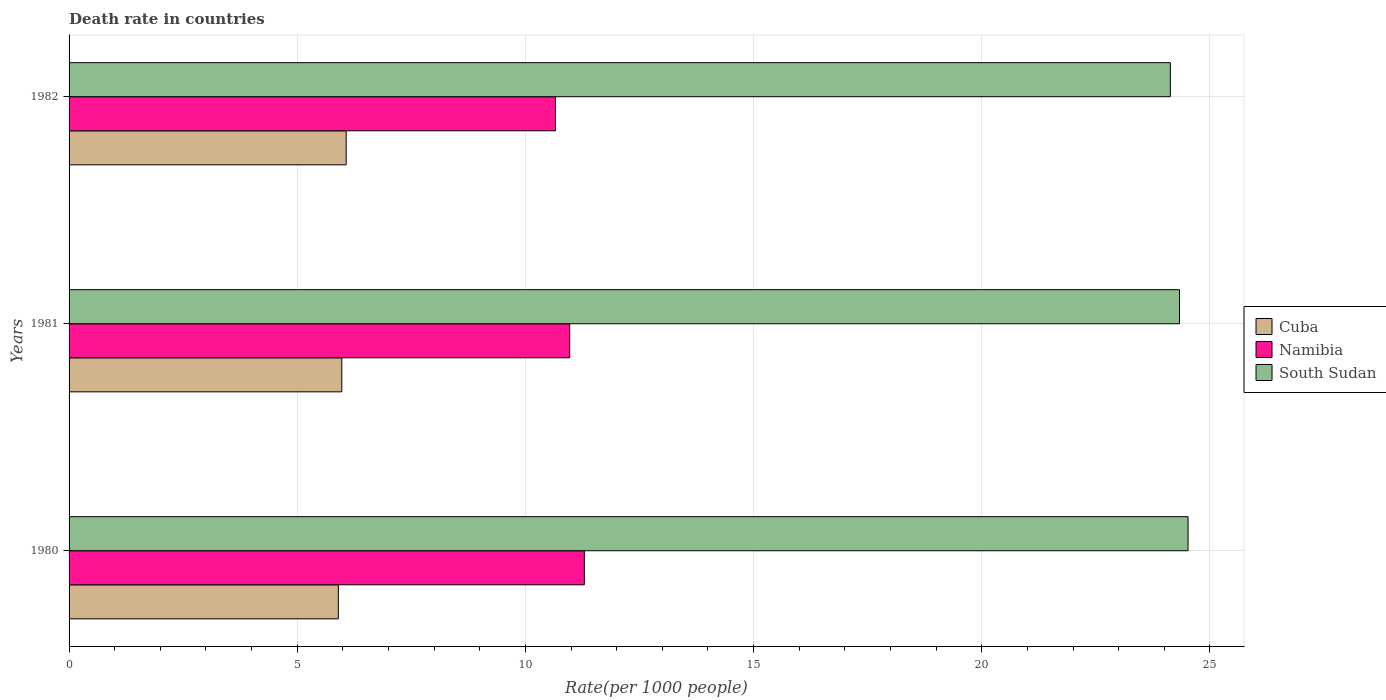How many different coloured bars are there?
Provide a short and direct response. 3. How many groups of bars are there?
Provide a short and direct response. 3. Are the number of bars per tick equal to the number of legend labels?
Offer a very short reply. Yes. How many bars are there on the 3rd tick from the top?
Ensure brevity in your answer.  3. What is the label of the 1st group of bars from the top?
Offer a very short reply. 1982. What is the death rate in South Sudan in 1982?
Provide a short and direct response. 24.13. Across all years, what is the maximum death rate in Cuba?
Your answer should be compact. 6.07. Across all years, what is the minimum death rate in South Sudan?
Your answer should be compact. 24.13. In which year was the death rate in Namibia maximum?
Offer a very short reply. 1980. In which year was the death rate in Namibia minimum?
Ensure brevity in your answer.  1982. What is the total death rate in Cuba in the graph?
Offer a very short reply. 17.95. What is the difference between the death rate in South Sudan in 1980 and that in 1982?
Offer a terse response. 0.39. What is the difference between the death rate in Namibia in 1980 and the death rate in Cuba in 1982?
Provide a succinct answer. 5.22. What is the average death rate in Cuba per year?
Make the answer very short. 5.98. In the year 1981, what is the difference between the death rate in Cuba and death rate in South Sudan?
Keep it short and to the point. -18.36. In how many years, is the death rate in Cuba greater than 20 ?
Your response must be concise. 0. What is the ratio of the death rate in South Sudan in 1981 to that in 1982?
Offer a very short reply. 1.01. Is the death rate in Namibia in 1980 less than that in 1981?
Ensure brevity in your answer.  No. Is the difference between the death rate in Cuba in 1980 and 1982 greater than the difference between the death rate in South Sudan in 1980 and 1982?
Provide a succinct answer. No. What is the difference between the highest and the second highest death rate in Cuba?
Offer a very short reply. 0.1. What is the difference between the highest and the lowest death rate in Cuba?
Make the answer very short. 0.17. In how many years, is the death rate in Namibia greater than the average death rate in Namibia taken over all years?
Offer a very short reply. 1. Is the sum of the death rate in Namibia in 1980 and 1981 greater than the maximum death rate in South Sudan across all years?
Keep it short and to the point. No. What does the 2nd bar from the top in 1981 represents?
Give a very brief answer. Namibia. What does the 2nd bar from the bottom in 1982 represents?
Keep it short and to the point. Namibia. How many bars are there?
Keep it short and to the point. 9. Are the values on the major ticks of X-axis written in scientific E-notation?
Your response must be concise. No. Does the graph contain any zero values?
Offer a terse response. No. Does the graph contain grids?
Offer a terse response. Yes. Where does the legend appear in the graph?
Give a very brief answer. Center right. How many legend labels are there?
Offer a terse response. 3. What is the title of the graph?
Your answer should be compact. Death rate in countries. What is the label or title of the X-axis?
Offer a very short reply. Rate(per 1000 people). What is the Rate(per 1000 people) in Namibia in 1980?
Ensure brevity in your answer.  11.29. What is the Rate(per 1000 people) of South Sudan in 1980?
Keep it short and to the point. 24.52. What is the Rate(per 1000 people) of Cuba in 1981?
Provide a short and direct response. 5.98. What is the Rate(per 1000 people) in Namibia in 1981?
Your answer should be compact. 10.97. What is the Rate(per 1000 people) in South Sudan in 1981?
Provide a succinct answer. 24.33. What is the Rate(per 1000 people) of Cuba in 1982?
Give a very brief answer. 6.07. What is the Rate(per 1000 people) in Namibia in 1982?
Offer a very short reply. 10.66. What is the Rate(per 1000 people) in South Sudan in 1982?
Keep it short and to the point. 24.13. Across all years, what is the maximum Rate(per 1000 people) of Cuba?
Offer a terse response. 6.07. Across all years, what is the maximum Rate(per 1000 people) of Namibia?
Your answer should be very brief. 11.29. Across all years, what is the maximum Rate(per 1000 people) of South Sudan?
Ensure brevity in your answer.  24.52. Across all years, what is the minimum Rate(per 1000 people) in Cuba?
Offer a very short reply. 5.9. Across all years, what is the minimum Rate(per 1000 people) of Namibia?
Your answer should be very brief. 10.66. Across all years, what is the minimum Rate(per 1000 people) of South Sudan?
Give a very brief answer. 24.13. What is the total Rate(per 1000 people) in Cuba in the graph?
Your response must be concise. 17.95. What is the total Rate(per 1000 people) in Namibia in the graph?
Ensure brevity in your answer.  32.92. What is the total Rate(per 1000 people) of South Sudan in the graph?
Provide a short and direct response. 72.98. What is the difference between the Rate(per 1000 people) in Cuba in 1980 and that in 1981?
Your answer should be compact. -0.08. What is the difference between the Rate(per 1000 people) of Namibia in 1980 and that in 1981?
Your response must be concise. 0.32. What is the difference between the Rate(per 1000 people) of South Sudan in 1980 and that in 1981?
Your answer should be compact. 0.19. What is the difference between the Rate(per 1000 people) in Cuba in 1980 and that in 1982?
Make the answer very short. -0.17. What is the difference between the Rate(per 1000 people) of Namibia in 1980 and that in 1982?
Keep it short and to the point. 0.63. What is the difference between the Rate(per 1000 people) in South Sudan in 1980 and that in 1982?
Your answer should be compact. 0.39. What is the difference between the Rate(per 1000 people) in Cuba in 1981 and that in 1982?
Give a very brief answer. -0.1. What is the difference between the Rate(per 1000 people) of Namibia in 1981 and that in 1982?
Provide a succinct answer. 0.31. What is the difference between the Rate(per 1000 people) in South Sudan in 1981 and that in 1982?
Your answer should be very brief. 0.2. What is the difference between the Rate(per 1000 people) of Cuba in 1980 and the Rate(per 1000 people) of Namibia in 1981?
Your answer should be compact. -5.07. What is the difference between the Rate(per 1000 people) in Cuba in 1980 and the Rate(per 1000 people) in South Sudan in 1981?
Provide a succinct answer. -18.43. What is the difference between the Rate(per 1000 people) of Namibia in 1980 and the Rate(per 1000 people) of South Sudan in 1981?
Make the answer very short. -13.04. What is the difference between the Rate(per 1000 people) in Cuba in 1980 and the Rate(per 1000 people) in Namibia in 1982?
Your response must be concise. -4.76. What is the difference between the Rate(per 1000 people) of Cuba in 1980 and the Rate(per 1000 people) of South Sudan in 1982?
Your response must be concise. -18.23. What is the difference between the Rate(per 1000 people) in Namibia in 1980 and the Rate(per 1000 people) in South Sudan in 1982?
Keep it short and to the point. -12.84. What is the difference between the Rate(per 1000 people) in Cuba in 1981 and the Rate(per 1000 people) in Namibia in 1982?
Your response must be concise. -4.68. What is the difference between the Rate(per 1000 people) of Cuba in 1981 and the Rate(per 1000 people) of South Sudan in 1982?
Your response must be concise. -18.16. What is the difference between the Rate(per 1000 people) in Namibia in 1981 and the Rate(per 1000 people) in South Sudan in 1982?
Offer a very short reply. -13.16. What is the average Rate(per 1000 people) of Cuba per year?
Your response must be concise. 5.98. What is the average Rate(per 1000 people) of Namibia per year?
Offer a very short reply. 10.97. What is the average Rate(per 1000 people) in South Sudan per year?
Provide a succinct answer. 24.33. In the year 1980, what is the difference between the Rate(per 1000 people) of Cuba and Rate(per 1000 people) of Namibia?
Keep it short and to the point. -5.39. In the year 1980, what is the difference between the Rate(per 1000 people) in Cuba and Rate(per 1000 people) in South Sudan?
Ensure brevity in your answer.  -18.62. In the year 1980, what is the difference between the Rate(per 1000 people) in Namibia and Rate(per 1000 people) in South Sudan?
Ensure brevity in your answer.  -13.23. In the year 1981, what is the difference between the Rate(per 1000 people) in Cuba and Rate(per 1000 people) in Namibia?
Your response must be concise. -4.99. In the year 1981, what is the difference between the Rate(per 1000 people) in Cuba and Rate(per 1000 people) in South Sudan?
Keep it short and to the point. -18.36. In the year 1981, what is the difference between the Rate(per 1000 people) of Namibia and Rate(per 1000 people) of South Sudan?
Provide a succinct answer. -13.36. In the year 1982, what is the difference between the Rate(per 1000 people) of Cuba and Rate(per 1000 people) of Namibia?
Make the answer very short. -4.59. In the year 1982, what is the difference between the Rate(per 1000 people) in Cuba and Rate(per 1000 people) in South Sudan?
Offer a very short reply. -18.06. In the year 1982, what is the difference between the Rate(per 1000 people) of Namibia and Rate(per 1000 people) of South Sudan?
Provide a succinct answer. -13.47. What is the ratio of the Rate(per 1000 people) of Cuba in 1980 to that in 1981?
Offer a terse response. 0.99. What is the ratio of the Rate(per 1000 people) of Namibia in 1980 to that in 1981?
Your response must be concise. 1.03. What is the ratio of the Rate(per 1000 people) in South Sudan in 1980 to that in 1981?
Your answer should be very brief. 1.01. What is the ratio of the Rate(per 1000 people) of Cuba in 1980 to that in 1982?
Your answer should be very brief. 0.97. What is the ratio of the Rate(per 1000 people) in Namibia in 1980 to that in 1982?
Your answer should be very brief. 1.06. What is the ratio of the Rate(per 1000 people) of South Sudan in 1980 to that in 1982?
Your answer should be very brief. 1.02. What is the ratio of the Rate(per 1000 people) in Cuba in 1981 to that in 1982?
Your answer should be very brief. 0.98. What is the ratio of the Rate(per 1000 people) of Namibia in 1981 to that in 1982?
Your answer should be very brief. 1.03. What is the ratio of the Rate(per 1000 people) of South Sudan in 1981 to that in 1982?
Your response must be concise. 1.01. What is the difference between the highest and the second highest Rate(per 1000 people) of Cuba?
Make the answer very short. 0.1. What is the difference between the highest and the second highest Rate(per 1000 people) in Namibia?
Provide a short and direct response. 0.32. What is the difference between the highest and the second highest Rate(per 1000 people) of South Sudan?
Provide a short and direct response. 0.19. What is the difference between the highest and the lowest Rate(per 1000 people) in Cuba?
Make the answer very short. 0.17. What is the difference between the highest and the lowest Rate(per 1000 people) in Namibia?
Your answer should be very brief. 0.63. What is the difference between the highest and the lowest Rate(per 1000 people) in South Sudan?
Your answer should be compact. 0.39. 